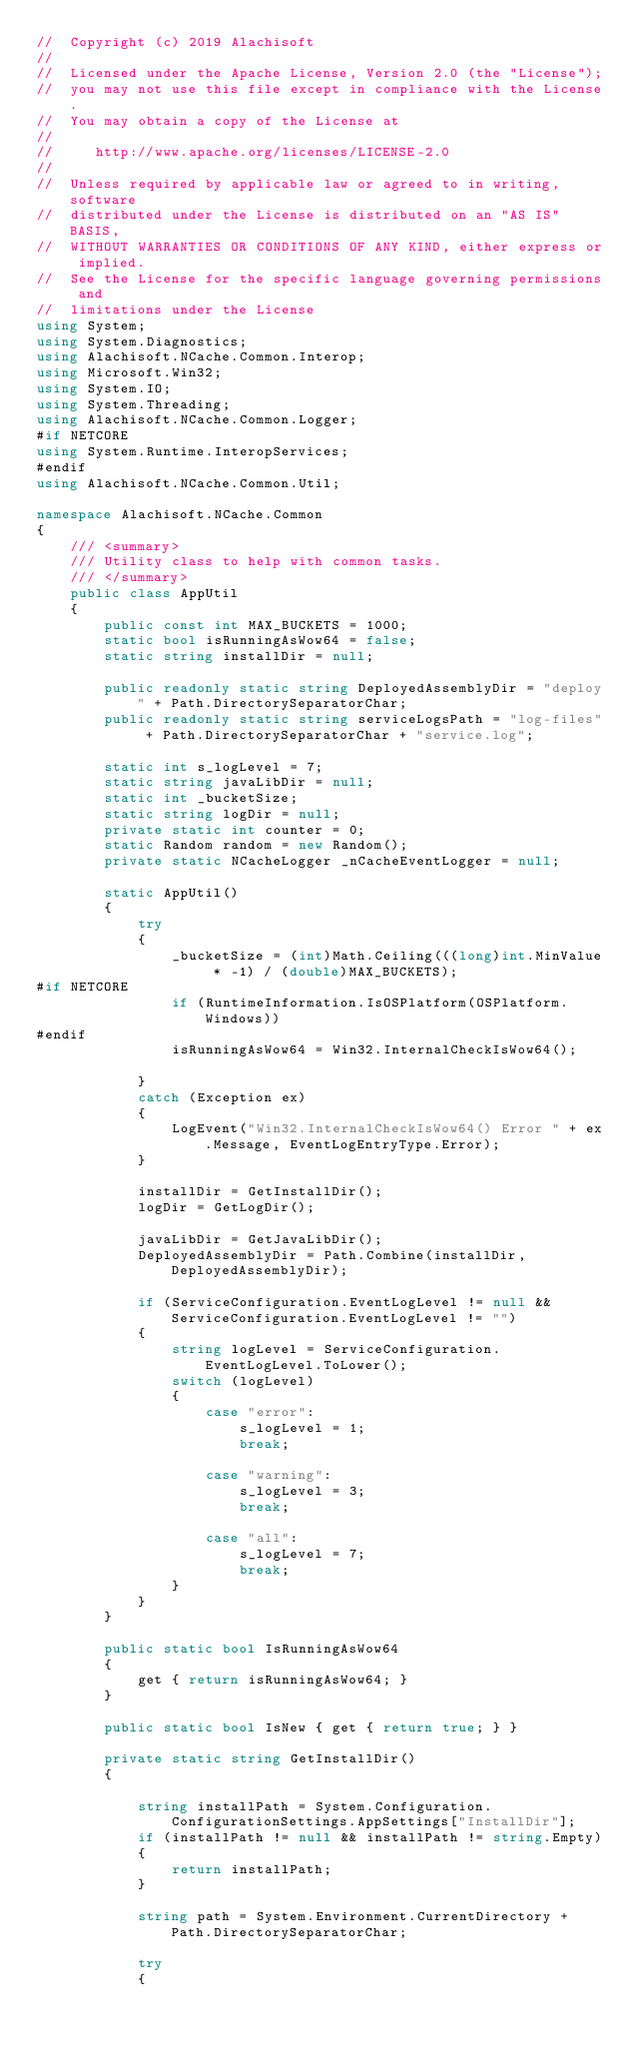<code> <loc_0><loc_0><loc_500><loc_500><_C#_>//  Copyright (c) 2019 Alachisoft
//  
//  Licensed under the Apache License, Version 2.0 (the "License");
//  you may not use this file except in compliance with the License.
//  You may obtain a copy of the License at
//  
//     http://www.apache.org/licenses/LICENSE-2.0
//  
//  Unless required by applicable law or agreed to in writing, software
//  distributed under the License is distributed on an "AS IS" BASIS,
//  WITHOUT WARRANTIES OR CONDITIONS OF ANY KIND, either express or implied.
//  See the License for the specific language governing permissions and
//  limitations under the License
using System;
using System.Diagnostics;
using Alachisoft.NCache.Common.Interop;
using Microsoft.Win32;
using System.IO;
using System.Threading;
using Alachisoft.NCache.Common.Logger;
#if NETCORE 
using System.Runtime.InteropServices;
#endif
using Alachisoft.NCache.Common.Util;

namespace Alachisoft.NCache.Common
{
    /// <summary>
    /// Utility class to help with common tasks.
    /// </summary>
    public class AppUtil
    {
        public const int MAX_BUCKETS = 1000;
        static bool isRunningAsWow64 = false;
        static string installDir = null;

        public readonly static string DeployedAssemblyDir = "deploy" + Path.DirectorySeparatorChar;
        public readonly static string serviceLogsPath = "log-files" + Path.DirectorySeparatorChar + "service.log";

        static int s_logLevel = 7;
        static string javaLibDir = null;
        static int _bucketSize;
        static string logDir = null;
        private static int counter = 0;
        static Random random = new Random();
        private static NCacheLogger _nCacheEventLogger = null;

        static AppUtil()
        {
            try
            {
                _bucketSize = (int)Math.Ceiling(((long)int.MinValue * -1) / (double)MAX_BUCKETS);
#if NETCORE 
                if (RuntimeInformation.IsOSPlatform(OSPlatform.Windows))
#endif
                isRunningAsWow64 = Win32.InternalCheckIsWow64();

            }
            catch (Exception ex)
            {
                LogEvent("Win32.InternalCheckIsWow64() Error " + ex.Message, EventLogEntryType.Error);
            }

            installDir = GetInstallDir();
            logDir = GetLogDir();

            javaLibDir = GetJavaLibDir();
            DeployedAssemblyDir = Path.Combine(installDir, DeployedAssemblyDir);

            if (ServiceConfiguration.EventLogLevel != null && ServiceConfiguration.EventLogLevel != "")
            {
                string logLevel = ServiceConfiguration.EventLogLevel.ToLower();
                switch (logLevel)
                {
                    case "error":
                        s_logLevel = 1;
                        break;

                    case "warning":
                        s_logLevel = 3;
                        break;

                    case "all":
                        s_logLevel = 7;
                        break;
                }
            }
        }
        
        public static bool IsRunningAsWow64
        {
            get { return isRunningAsWow64; }
        }

        public static bool IsNew { get { return true; } }

        private static string GetInstallDir()
        {

            string installPath = System.Configuration.ConfigurationSettings.AppSettings["InstallDir"];
            if (installPath != null && installPath != string.Empty)
            {
                return installPath;
            }

            string path = System.Environment.CurrentDirectory + Path.DirectorySeparatorChar;

            try
            {</code> 